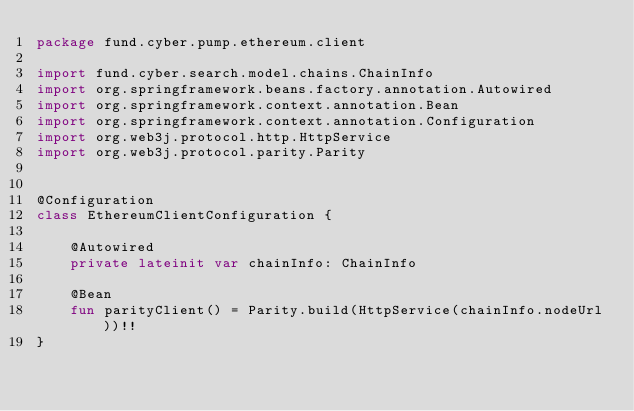Convert code to text. <code><loc_0><loc_0><loc_500><loc_500><_Kotlin_>package fund.cyber.pump.ethereum.client

import fund.cyber.search.model.chains.ChainInfo
import org.springframework.beans.factory.annotation.Autowired
import org.springframework.context.annotation.Bean
import org.springframework.context.annotation.Configuration
import org.web3j.protocol.http.HttpService
import org.web3j.protocol.parity.Parity


@Configuration
class EthereumClientConfiguration {

    @Autowired
    private lateinit var chainInfo: ChainInfo

    @Bean
    fun parityClient() = Parity.build(HttpService(chainInfo.nodeUrl))!!
}
</code> 